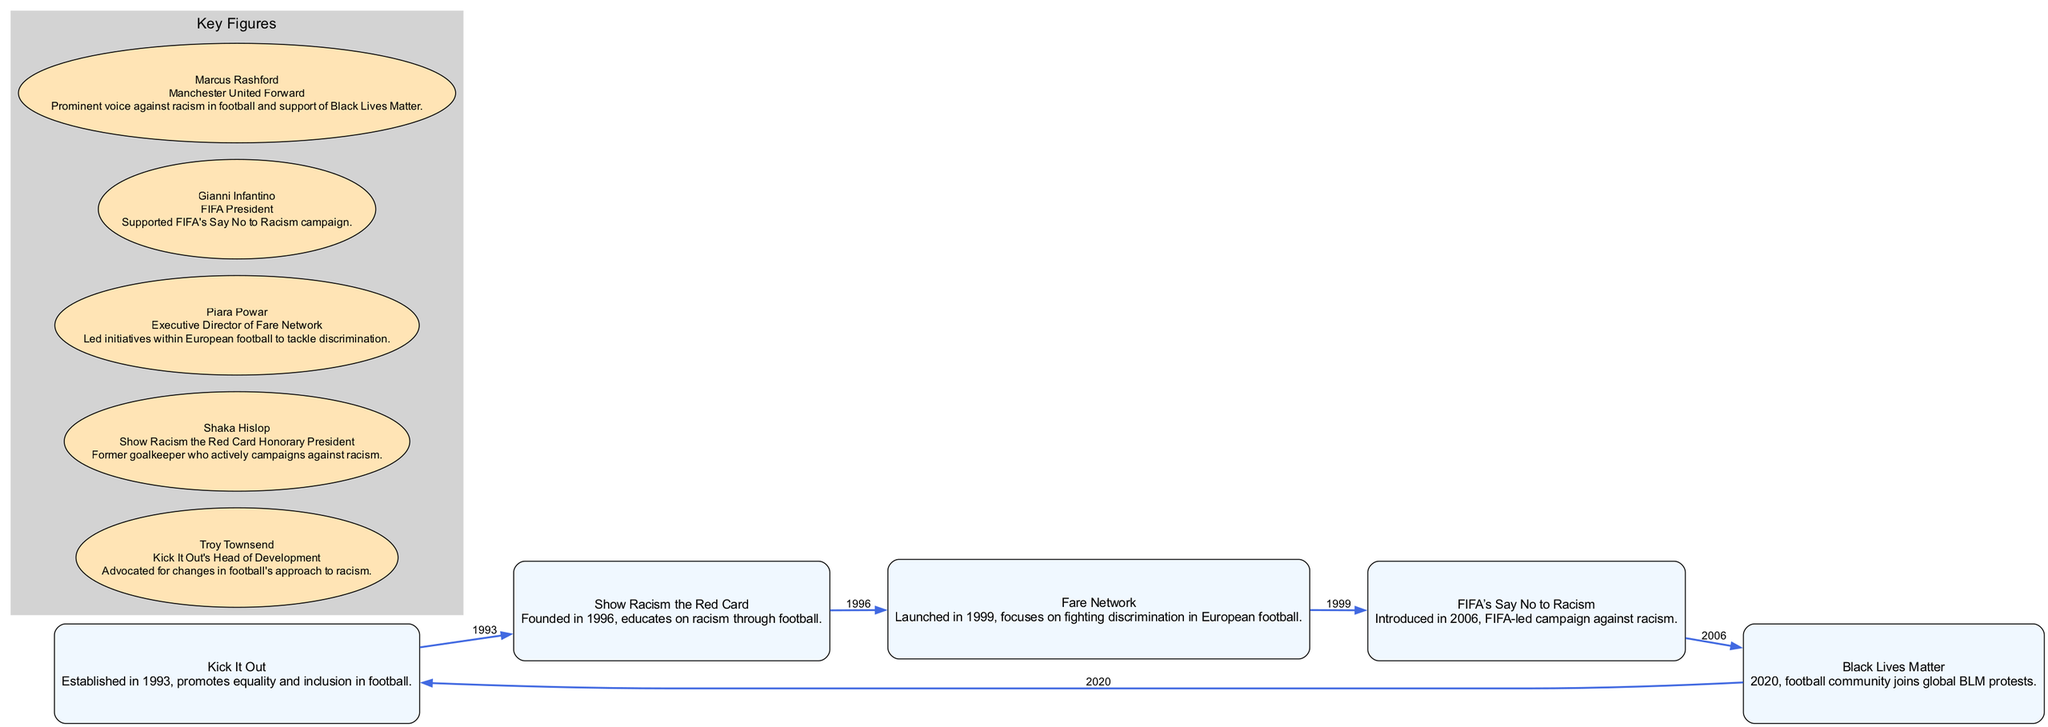What is the first anti-racism campaign mentioned in the diagram? The diagram lists "Kick It Out" as the first campaign established in 1993. It is the first node from which other campaigns are derived.
Answer: Kick It Out How many notable anti-racism campaigns are featured in the diagram? The diagram shows a total of five nodes, each representing a different anti-racism campaign in football.
Answer: Five Which year marks the launch of "FIFA’s Say No to Racism"? The edge leading from "Fare Network" to "FIFA’s Say No to Racism" indicates that this campaign was introduced in 2006.
Answer: 2006 Who is the honorary president of "Show Racism the Red Card"? The description linked with the key figure "Shaka Hislop" specifies that he serves as the Honorary President of the "Show Racism the Red Card" campaign.
Answer: Shaka Hislop What campaign was introduced in the same year as "Black Lives Matter"? Looking at the diagram, "Black Lives Matter" was initiated in 2020 and it connects to "Kick It Out", but there is no other campaign mentioned being introduced that year. Thus, it's a standalone campaign without others in 2020.
Answer: None What key figure is linked to "Kick It Out"? "Troy Townsend", as noted in the key figures section, is directly involved with "Kick It Out" as their Head of Development.
Answer: Troy Townsend Which campaign focuses on fighting discrimination in European football? The node labeled "Fare Network" specifies its aim is to fight discrimination specifically within European football, as indicated in its description.
Answer: Fare Network From which campaign does "Show Racism the Red Card" emerge? The edge from "Kick It Out" to "Show Racism the Red Card" shows that "Show Racism the Red Card" was established after "Kick It Out" and is derived from it, indicating its direct emergence.
Answer: Kick It Out Who is a prominent voice against racism in football? "Marcus Rashford" is mentioned in the key figures section as a prominent voice against racism, especially for his support of "Black Lives Matter."
Answer: Marcus Rashford 